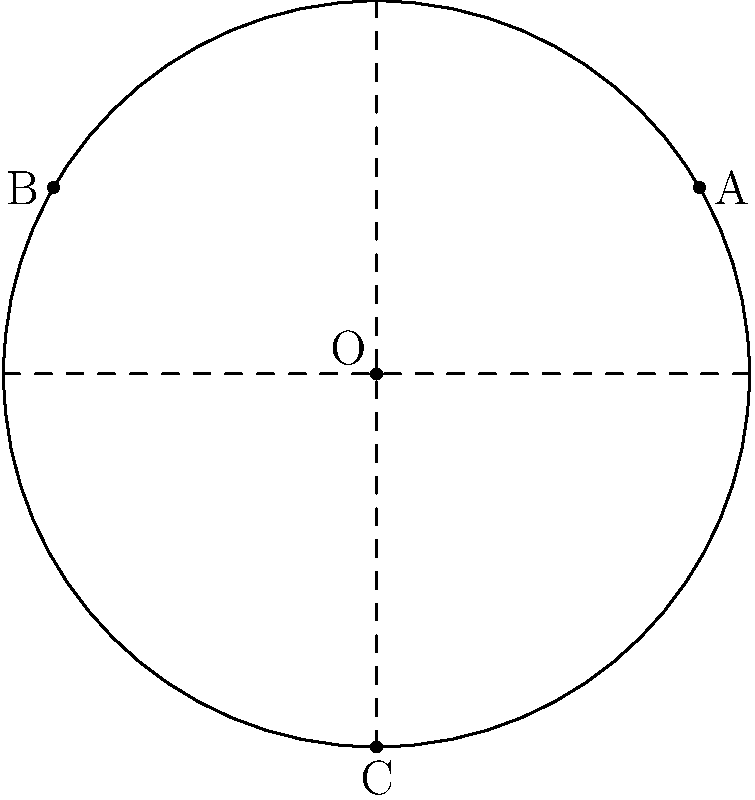In a circular savanna exhibit with a radius of 30 meters, you need to place three feeding stations (A, B, and C) to ensure optimal distribution of resources. The stations are located at the following polar coordinates: A($30, \frac{\pi}{6}$), B($30, \frac{5\pi}{6}$), and C($30, \frac{3\pi}{2}$). Calculate the total distance an animal would travel if it visited all three stations in the order A → B → C → A, rounded to the nearest meter. To solve this problem, we need to follow these steps:

1) First, we need to convert the polar coordinates to Cartesian coordinates:
   A: $(30 \cos(\frac{\pi}{6}), 30 \sin(\frac{\pi}{6})) \approx (25.98, 15)$
   B: $(30 \cos(\frac{5\pi}{6}), 30 \sin(\frac{5\pi}{6})) \approx (-25.98, 15)$
   C: $(30 \cos(\frac{3\pi}{2}), 30 \sin(\frac{3\pi}{2})) = (0, -30)$

2) Now, we can calculate the distances between each pair of points using the distance formula:
   $d = \sqrt{(x_2-x_1)^2 + (y_2-y_1)^2}$

   Distance A to B: $\sqrt{((-25.98)-25.98)^2 + (15-15)^2} = 51.96$
   Distance B to C: $\sqrt{(0-(-25.98))^2 + (-30-15)^2} = 51.96$
   Distance C to A: $\sqrt{(25.98-0)^2 + (15-(-30))^2} = 51.96$

3) The total distance is the sum of these three distances:
   Total distance = 51.96 + 51.96 + 51.96 = 155.88 meters

4) Rounding to the nearest meter:
   155.88 ≈ 156 meters

Therefore, an animal would travel approximately 156 meters to visit all three stations in the order A → B → C → A.
Answer: 156 meters 